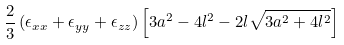<formula> <loc_0><loc_0><loc_500><loc_500>\frac { 2 } { 3 } \left ( \epsilon _ { x x } + \epsilon _ { y y } + \epsilon _ { z z } \right ) \left [ 3 a ^ { 2 } - 4 l ^ { 2 } - 2 l \sqrt { 3 a ^ { 2 } + 4 l ^ { 2 } } \right ]</formula> 